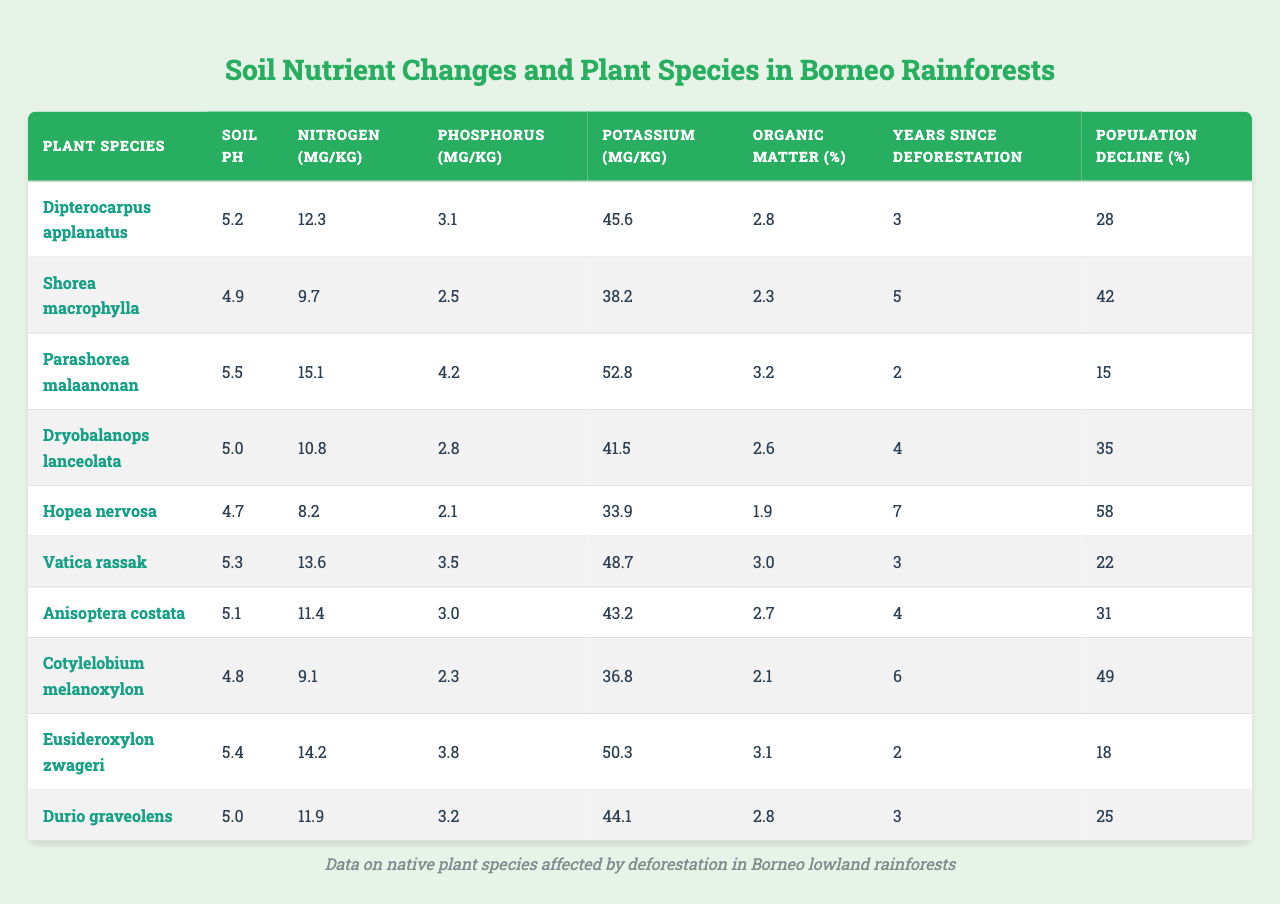What is the soil pH for Shorea macrophylla? In the table, I look for the row corresponding to Shorea macrophylla. The soil pH listed in that row is 4.9.
Answer: 4.9 Which plant species has the highest population decline percentage? I check the "Population Decline (%)" column and identify the maximum value. Hopea nervosa has the highest value at 58%.
Answer: 58% What is the average nitrogen content of the listed plant species? I sum the nitrogen values: (12.3 + 9.7 + 15.1 + 10.8 + 8.2 + 13.6 + 11.4 + 9.1 + 14.2 + 11.9) =  121.3 mg/kg. There are 10 species, so the average is 121.3 / 10 = 12.13 mg/kg.
Answer: 12.13 mg/kg Which plant has the lowest phosphorus content? I examine the phosphorus values in the table and find Cotylelobium melanoxylon has the lowest value of 2.3 mg/kg.
Answer: Cotylelobium melanoxylon How does the soil pH of Eusideroxylon zwageri compare to that of Dipterocarpus applanatus? The soil pH for Eusideroxylon zwageri is 5.4, while for Dipterocarpus applanatus it is 5.2. I compare these values, and since 5.4 is greater than 5.2, Eusideroxylon zwageri has a higher pH.
Answer: Eusideroxylon zwageri has a higher pH Is there a significant relationship between years since deforestation and population decline for any plant species? To analyze, I look at the "Years Since Deforestation" and "Population Decline (%)" columns. I find that as years increase, the population decline also tends to increase for most species. For example, Hopea nervosa is 7 years and has a 58% decline, while Parashorea malaanonan is 2 years with a 15% decline. This demonstrates a potential correlation.
Answer: Yes, there appears to be a relationship Which plant species has the highest organic matter content and how does it relate to nitrogen content? The highest organic matter is 3.2% for Parashorea malaanonan. Its nitrogen content is 15.1 mg/kg. I compare these values with other species; there’s no clear direct relationship, but Parashorea malaanonan does have above-average nitrogen relative to nitrogen content in other species.
Answer: Parashorea malaanonan; 3.2% organic matter and 15.1 mg/kg nitrogen What are the nitrogen and phosphorus levels of the plant with the longest time since deforestation? The species with the longest time since deforestation is Hopea nervosa at 7 years. I check the nitrogen level for this species and find it is 8.2 mg/kg, while the phosphorus level is 2.1 mg/kg.
Answer: 8.2 mg/kg nitrogen and 2.1 mg/kg phosphorus How do potassium levels affect population decline among the listed species? I review the potassium levels and the corresponding population decline percentages. Looking at the table, while there are variations, there's no consistent increasing or decreasing trend between potassium levels and population decline percentages across species. Thus no direct correlation can be definitively stated.
Answer: No clear correlation is observed 